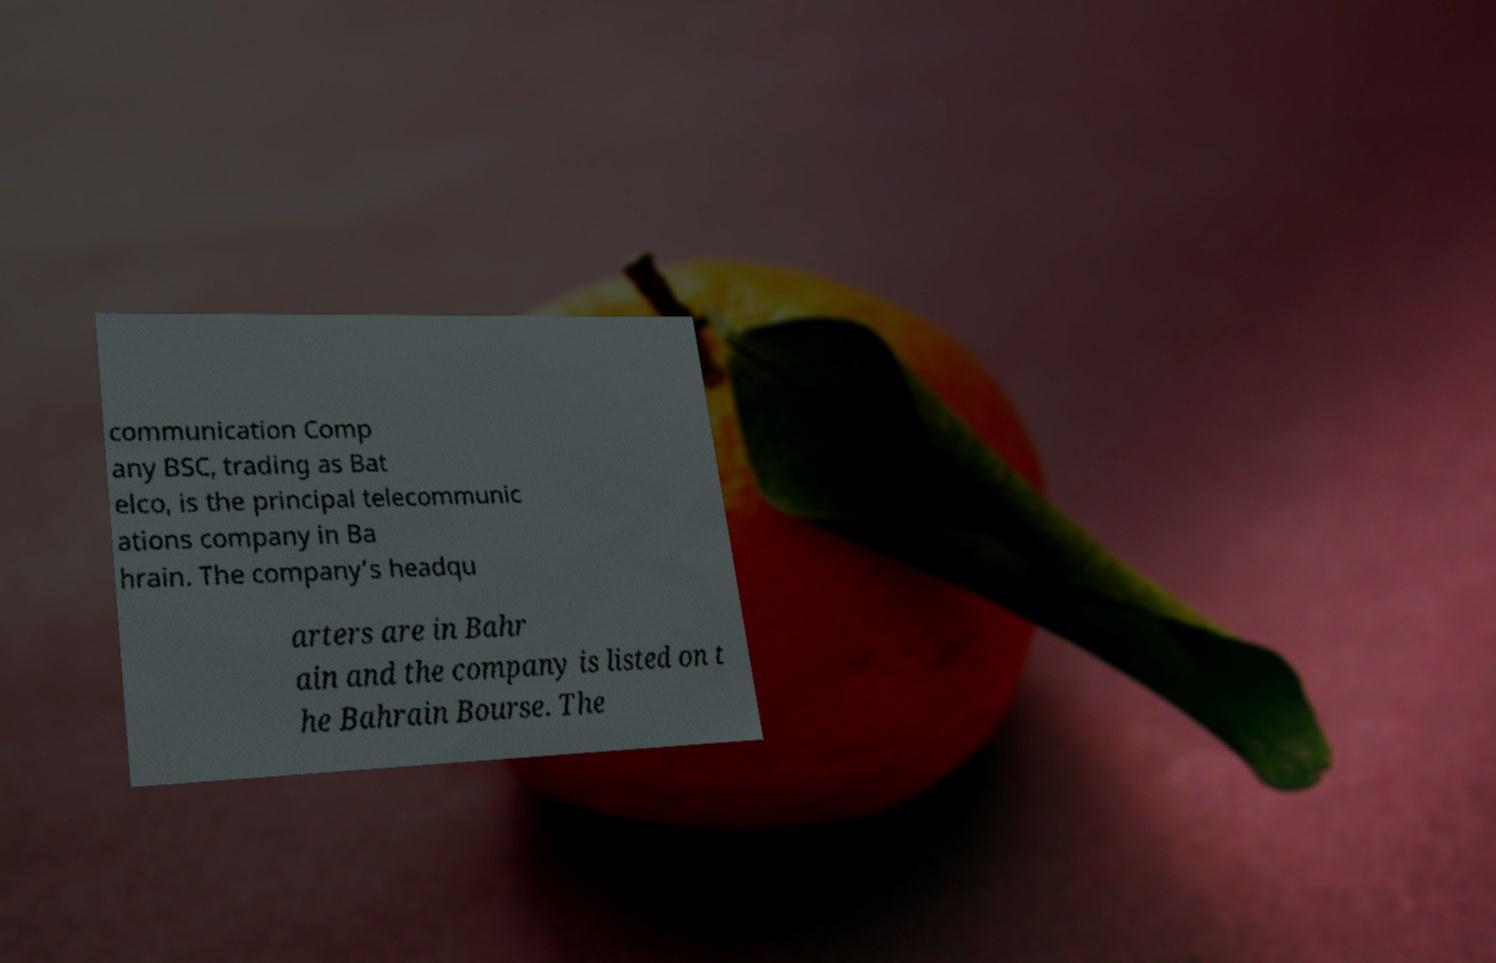Could you assist in decoding the text presented in this image and type it out clearly? communication Comp any BSC, trading as Bat elco, is the principal telecommunic ations company in Ba hrain. The company’s headqu arters are in Bahr ain and the company is listed on t he Bahrain Bourse. The 